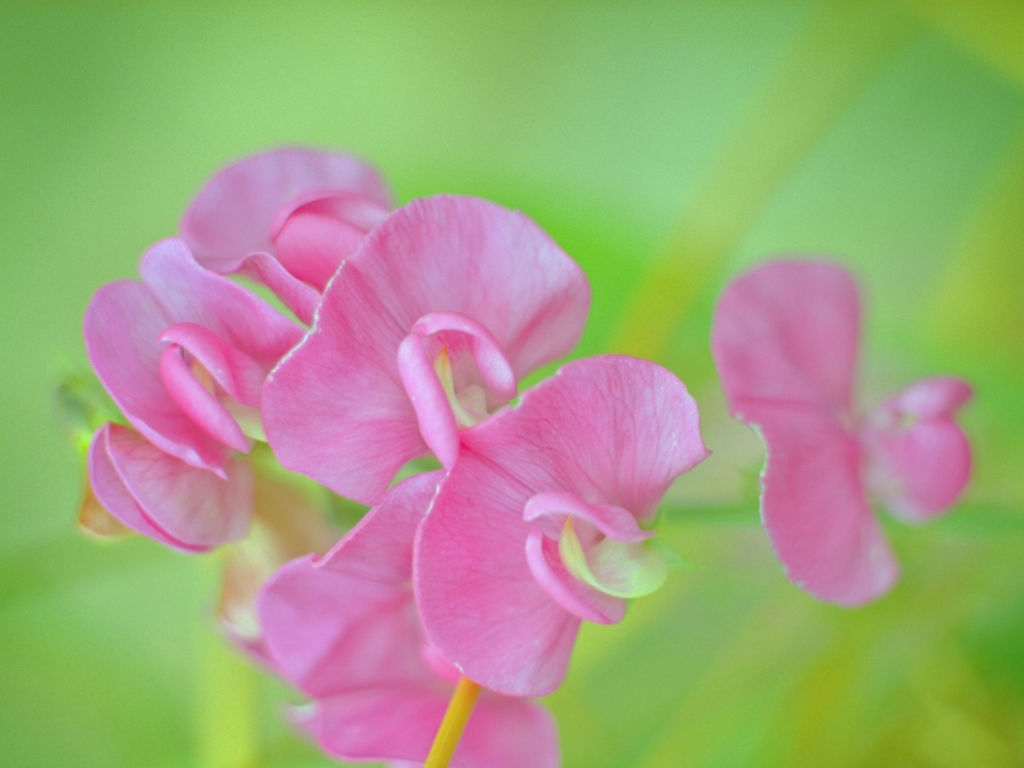Can you tell me more about the type of flower depicted in this image? Certainly! The image appears to showcase a cluster of pink sweet peas (Lathyrus odoratus), characterized by their pastel colors and butterfly-shaped blossoms. They are known for their enchanting fragrance and are popular in gardens and floral arrangements. 